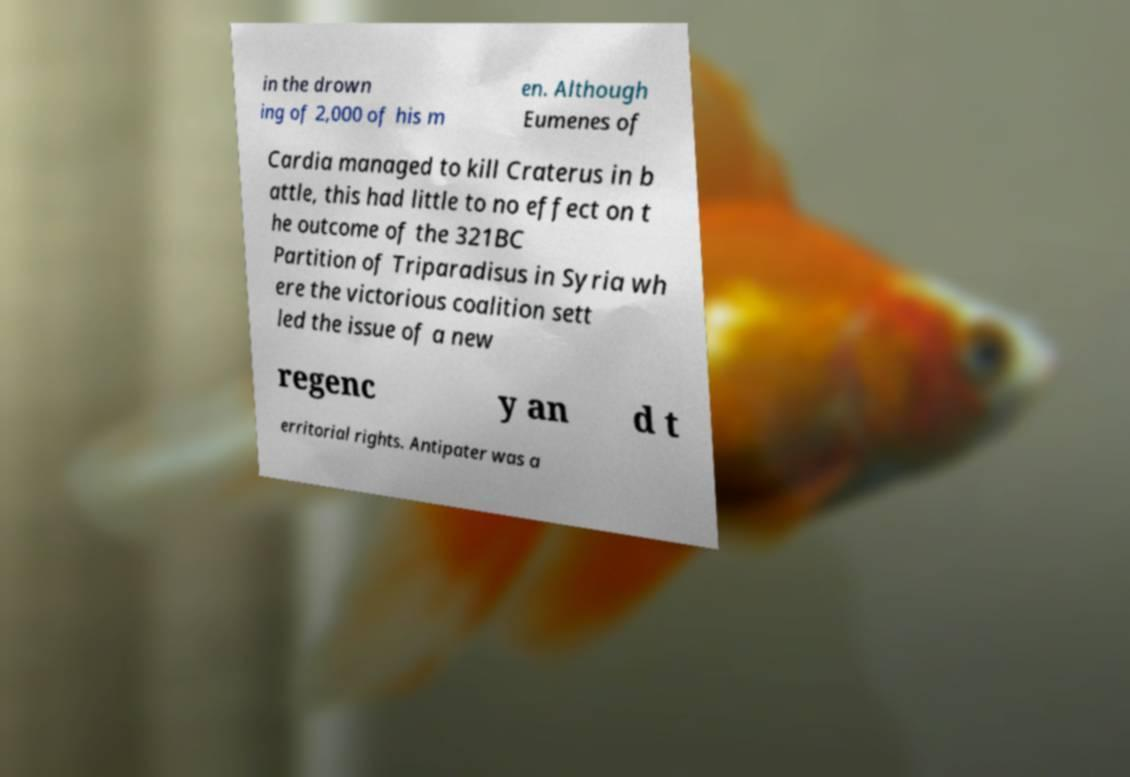Please identify and transcribe the text found in this image. in the drown ing of 2,000 of his m en. Although Eumenes of Cardia managed to kill Craterus in b attle, this had little to no effect on t he outcome of the 321BC Partition of Triparadisus in Syria wh ere the victorious coalition sett led the issue of a new regenc y an d t erritorial rights. Antipater was a 